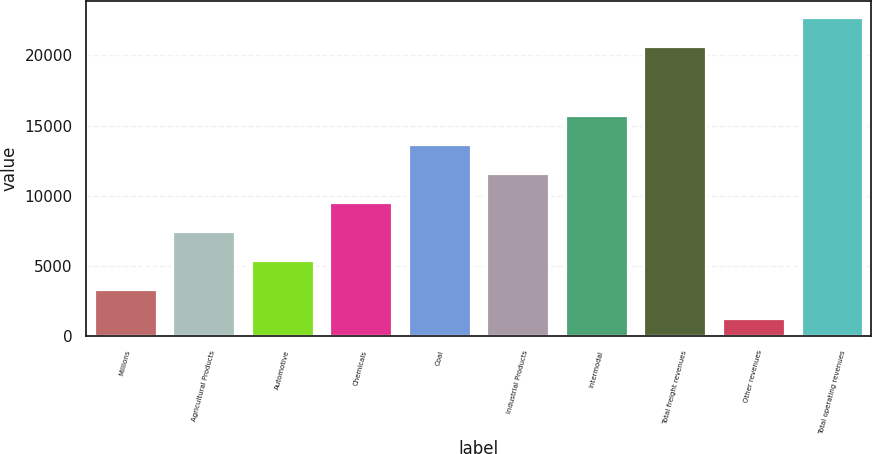<chart> <loc_0><loc_0><loc_500><loc_500><bar_chart><fcel>Millions<fcel>Agricultural Products<fcel>Automotive<fcel>Chemicals<fcel>Coal<fcel>Industrial Products<fcel>Intermodal<fcel>Total freight revenues<fcel>Other revenues<fcel>Total operating revenues<nl><fcel>3347.4<fcel>7484.2<fcel>5415.8<fcel>9552.6<fcel>13689.4<fcel>11621<fcel>15757.8<fcel>20684<fcel>1279<fcel>22752.4<nl></chart> 